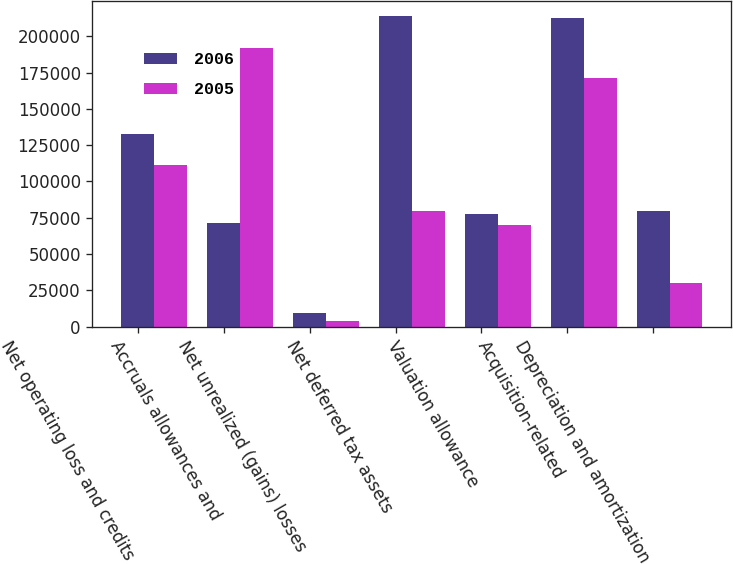Convert chart. <chart><loc_0><loc_0><loc_500><loc_500><stacked_bar_chart><ecel><fcel>Net operating loss and credits<fcel>Accruals allowances and<fcel>Net unrealized (gains) losses<fcel>Net deferred tax assets<fcel>Valuation allowance<fcel>Acquisition-related<fcel>Depreciation and amortization<nl><fcel>2006<fcel>132832<fcel>71504<fcel>9616<fcel>213952<fcel>77712<fcel>212702<fcel>79946<nl><fcel>2005<fcel>111133<fcel>192276<fcel>4024<fcel>79946<fcel>69777<fcel>171422<fcel>30139<nl></chart> 